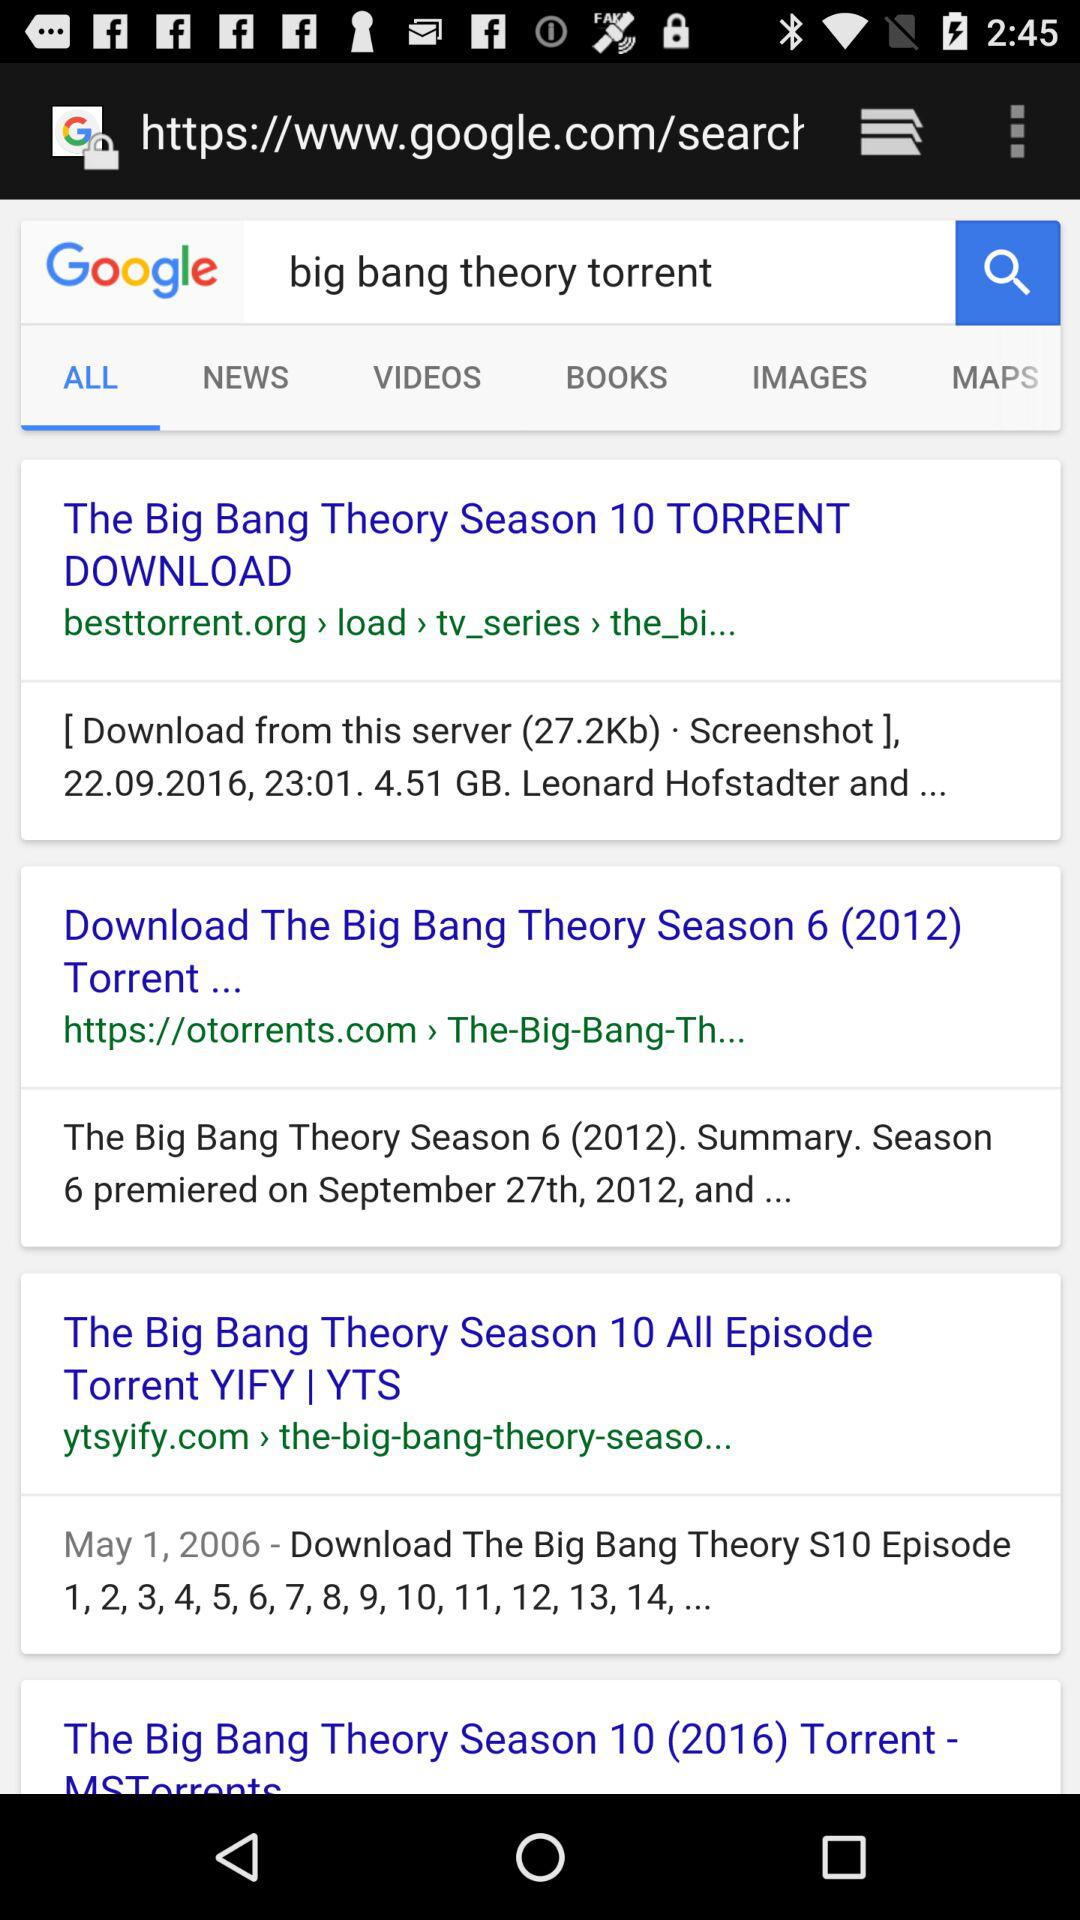Which tab is selected? The selected tab is "ALL". 